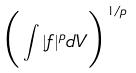Convert formula to latex. <formula><loc_0><loc_0><loc_500><loc_500>\Big { ( } \int | f | ^ { p } d V \Big { ) } ^ { 1 / p }</formula> 